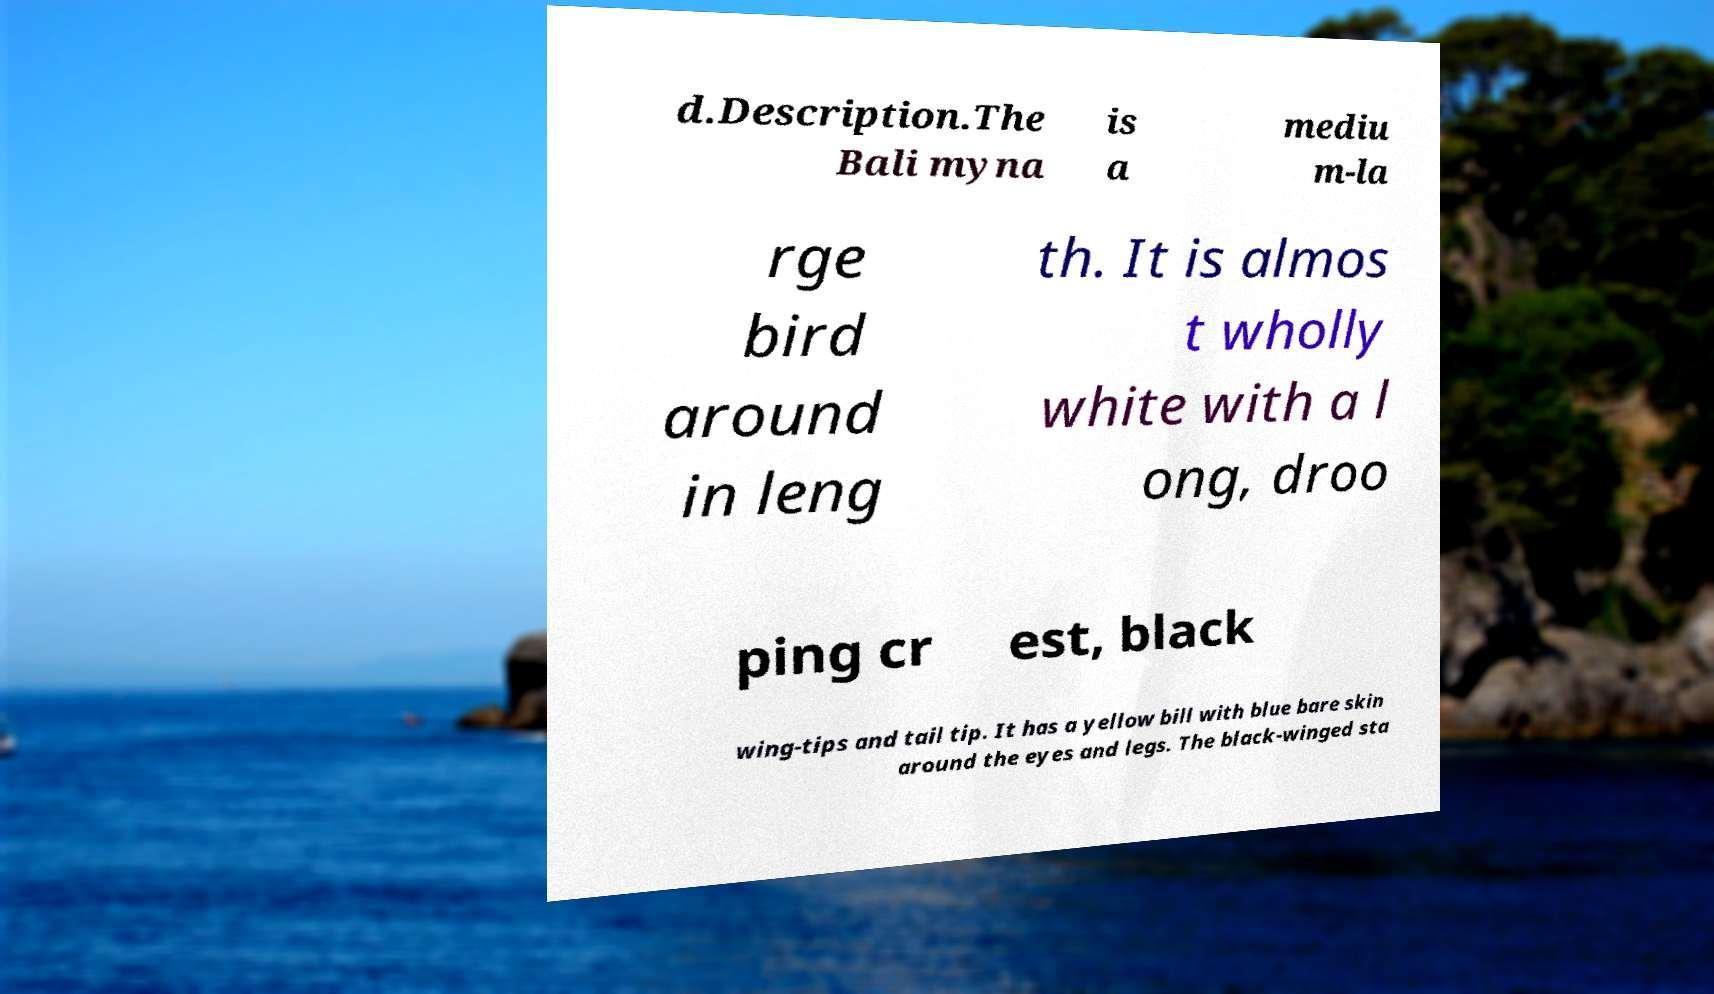Could you assist in decoding the text presented in this image and type it out clearly? d.Description.The Bali myna is a mediu m-la rge bird around in leng th. It is almos t wholly white with a l ong, droo ping cr est, black wing-tips and tail tip. It has a yellow bill with blue bare skin around the eyes and legs. The black-winged sta 